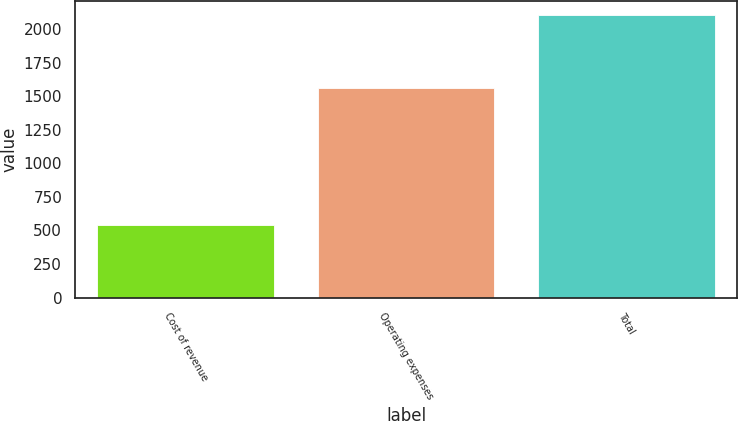Convert chart to OTSL. <chart><loc_0><loc_0><loc_500><loc_500><bar_chart><fcel>Cost of revenue<fcel>Operating expenses<fcel>Total<nl><fcel>543<fcel>1562.2<fcel>2105.2<nl></chart> 